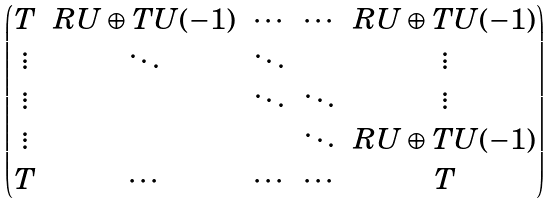Convert formula to latex. <formula><loc_0><loc_0><loc_500><loc_500>\begin{pmatrix} T & R U \oplus T U ( - 1 ) & \cdots & \cdots & R U \oplus T U ( - 1 ) \\ \vdots & \ddots & \ddots & & \vdots \\ \vdots & & \ddots & \ddots & \vdots \\ \vdots & & & \ddots & R U \oplus T U ( - 1 ) \\ T & \cdots & \cdots & \cdots & T \end{pmatrix}</formula> 